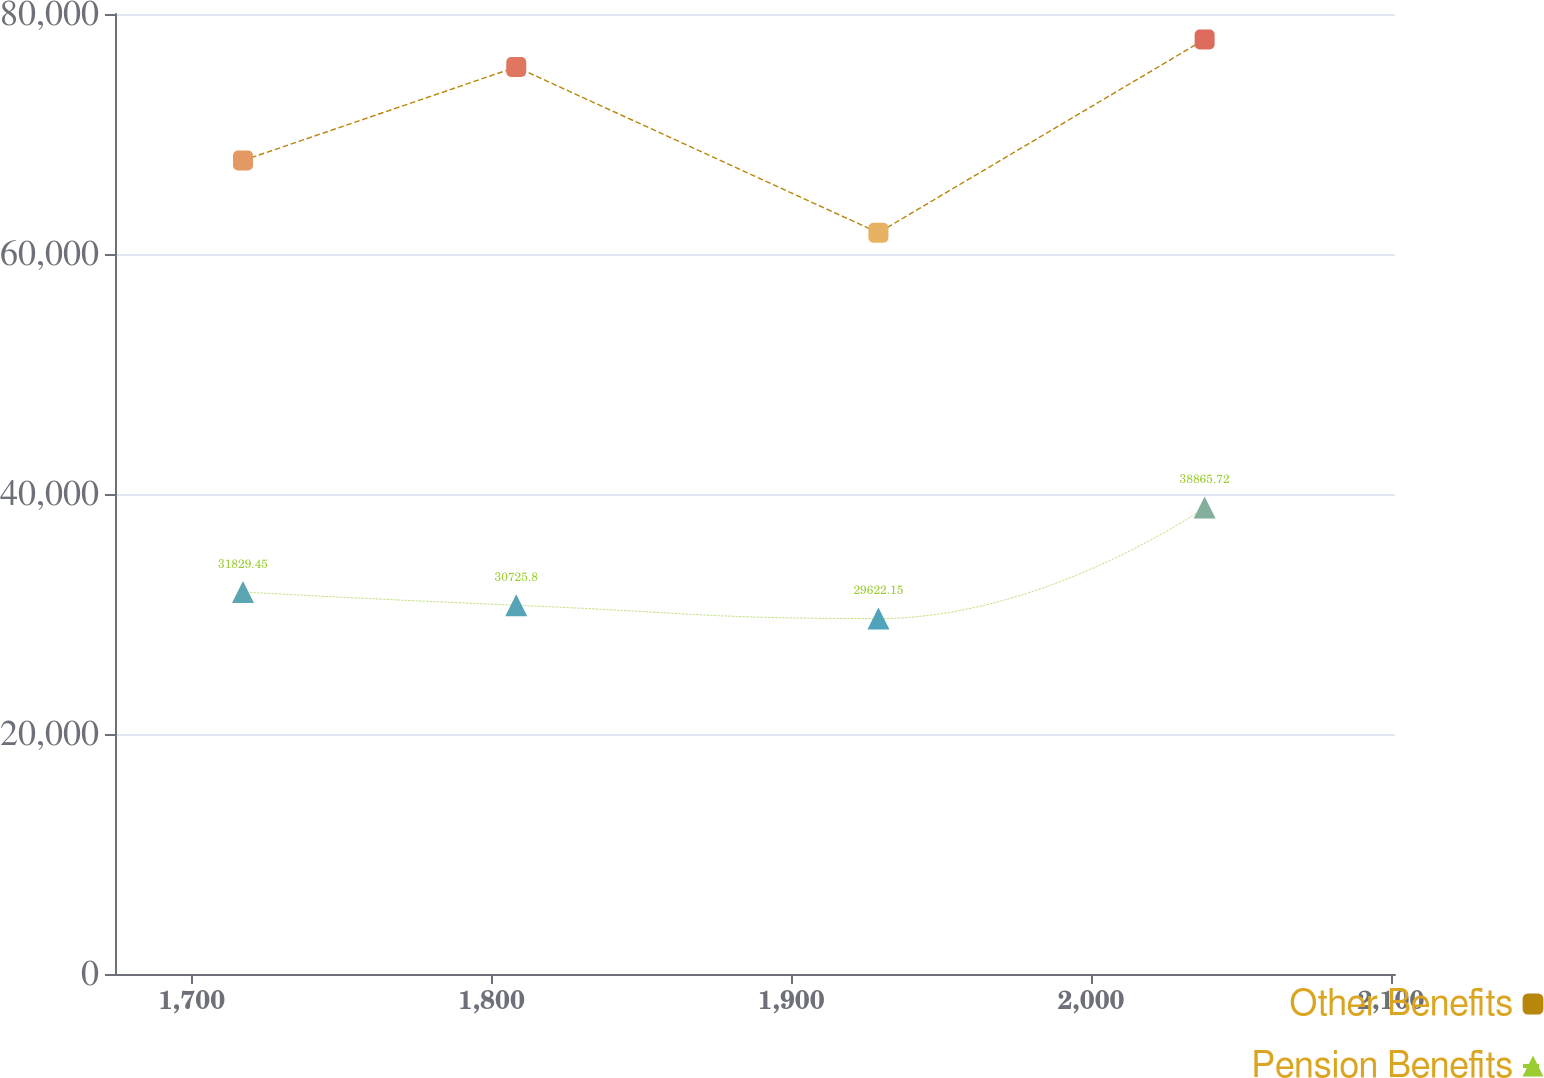Convert chart to OTSL. <chart><loc_0><loc_0><loc_500><loc_500><line_chart><ecel><fcel>Other Benefits<fcel>Pension Benefits<nl><fcel>1717.14<fcel>67794.3<fcel>31829.5<nl><fcel>1808.28<fcel>75577.7<fcel>30725.8<nl><fcel>1929.08<fcel>61772.3<fcel>29622.2<nl><fcel>2037.88<fcel>77881<fcel>38865.7<nl><fcel>2144.07<fcel>84805.8<fcel>40658.6<nl></chart> 